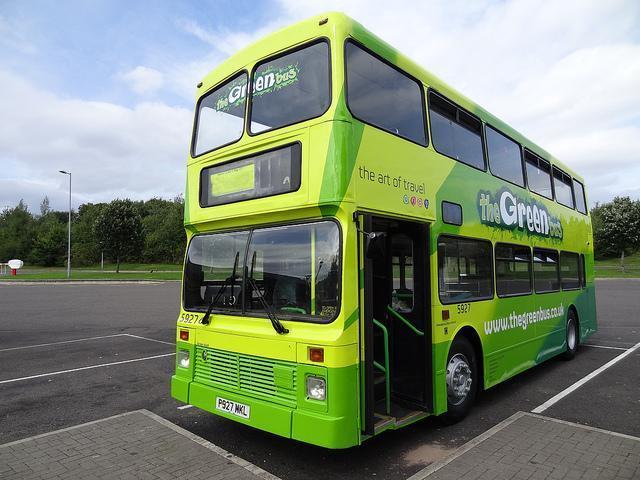How many men have a red baseball cap?
Give a very brief answer. 0. 